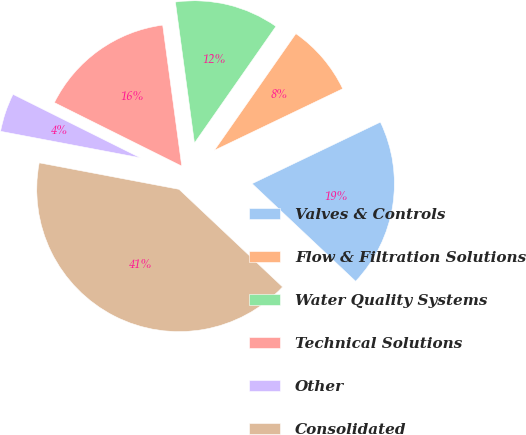Convert chart to OTSL. <chart><loc_0><loc_0><loc_500><loc_500><pie_chart><fcel>Valves & Controls<fcel>Flow & Filtration Solutions<fcel>Water Quality Systems<fcel>Technical Solutions<fcel>Other<fcel>Consolidated<nl><fcel>19.15%<fcel>8.18%<fcel>11.84%<fcel>15.5%<fcel>4.38%<fcel>40.95%<nl></chart> 